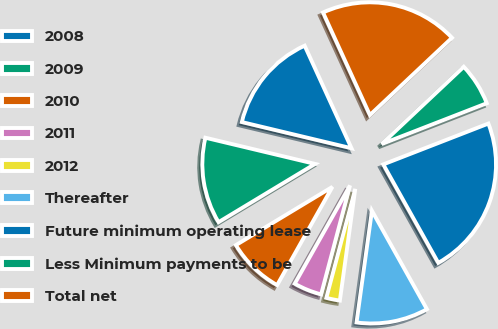<chart> <loc_0><loc_0><loc_500><loc_500><pie_chart><fcel>2008<fcel>2009<fcel>2010<fcel>2011<fcel>2012<fcel>Thereafter<fcel>Future minimum operating lease<fcel>Less Minimum payments to be<fcel>Total net<nl><fcel>14.45%<fcel>12.37%<fcel>8.2%<fcel>4.03%<fcel>1.95%<fcel>10.29%<fcel>22.79%<fcel>6.12%<fcel>19.8%<nl></chart> 